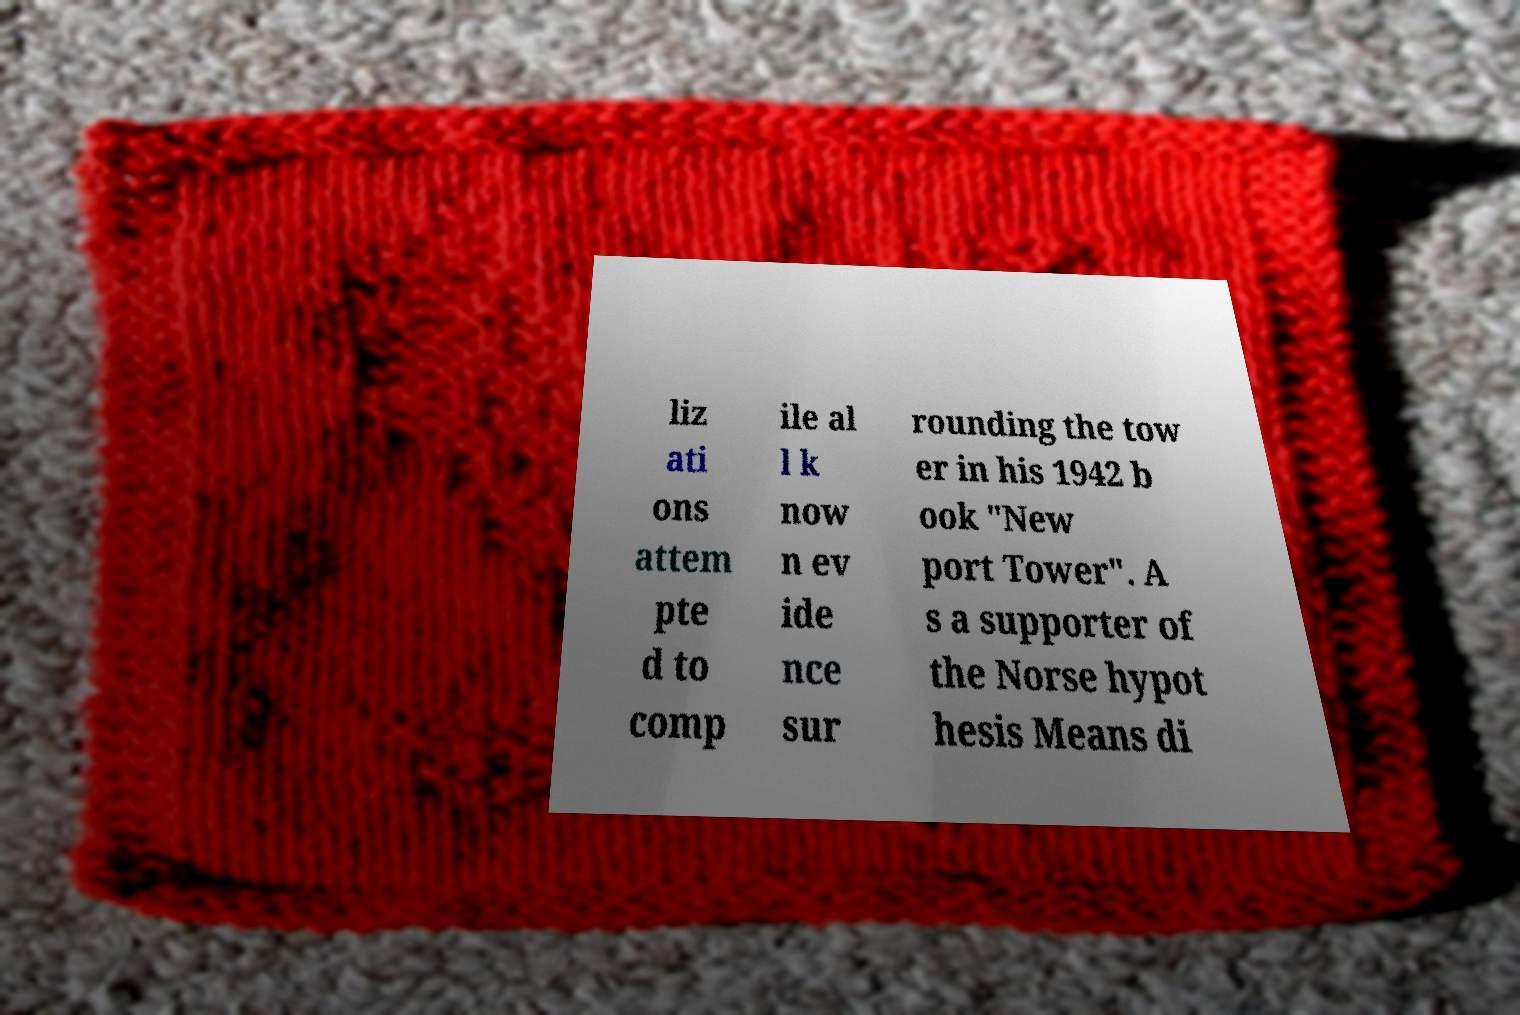There's text embedded in this image that I need extracted. Can you transcribe it verbatim? liz ati ons attem pte d to comp ile al l k now n ev ide nce sur rounding the tow er in his 1942 b ook "New port Tower". A s a supporter of the Norse hypot hesis Means di 